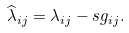<formula> <loc_0><loc_0><loc_500><loc_500>\widehat { \lambda } _ { i j } = \lambda _ { i j } - s g _ { i j } .</formula> 